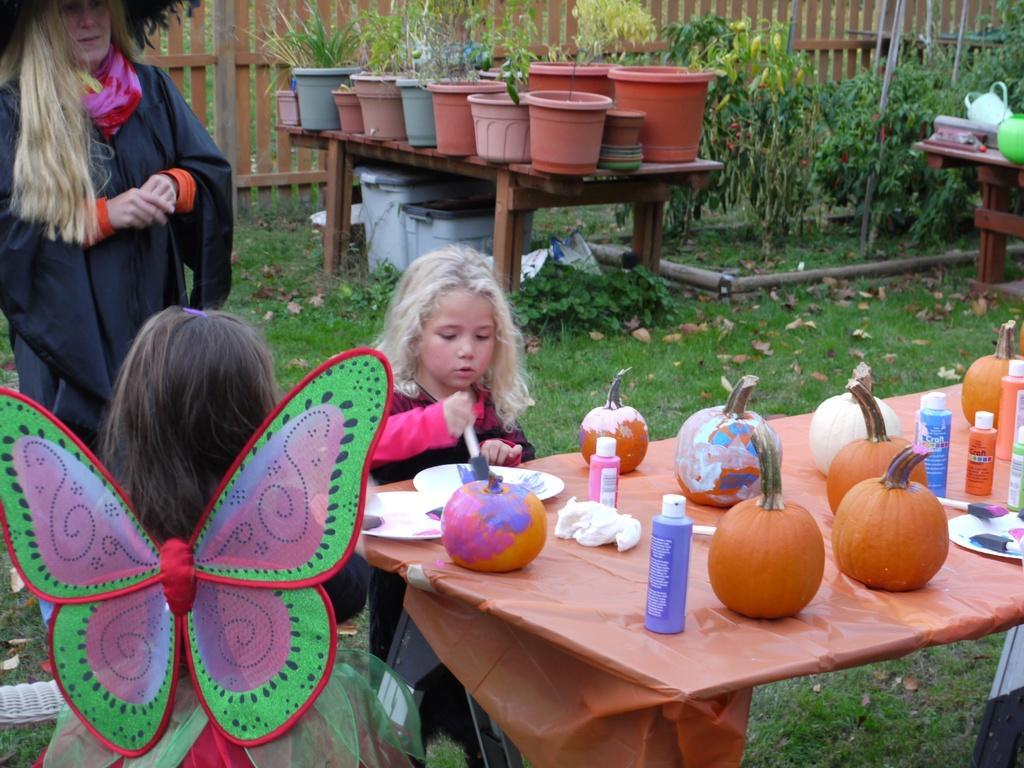How would you summarize this image in a sentence or two? This image is clicked outside. There are tables and on the tables, there are flower pots, pumpkins, painted, plates, brushes. There are girls in the middle. There is a woman on the left side. There are plants at the top. 